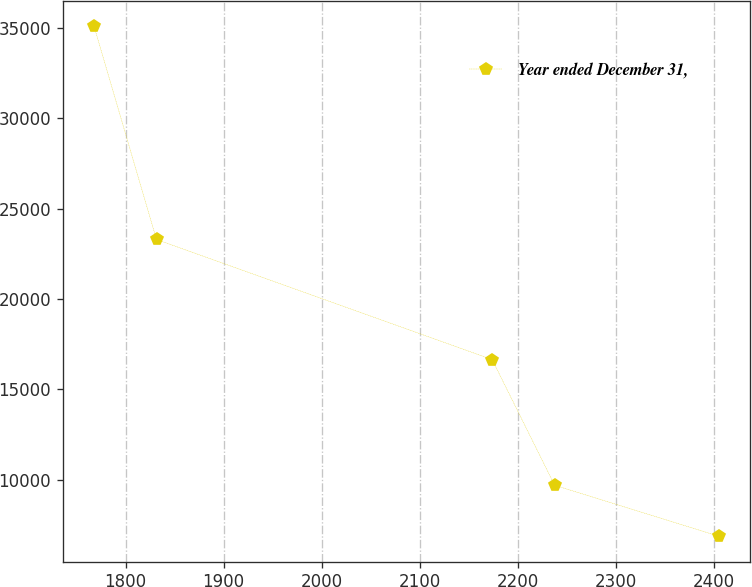Convert chart to OTSL. <chart><loc_0><loc_0><loc_500><loc_500><line_chart><ecel><fcel>Year ended December 31,<nl><fcel>1767.87<fcel>35106.1<nl><fcel>1831.57<fcel>23299.9<nl><fcel>2173.69<fcel>16652.3<nl><fcel>2237.39<fcel>9692.49<nl><fcel>2404.9<fcel>6868.75<nl></chart> 